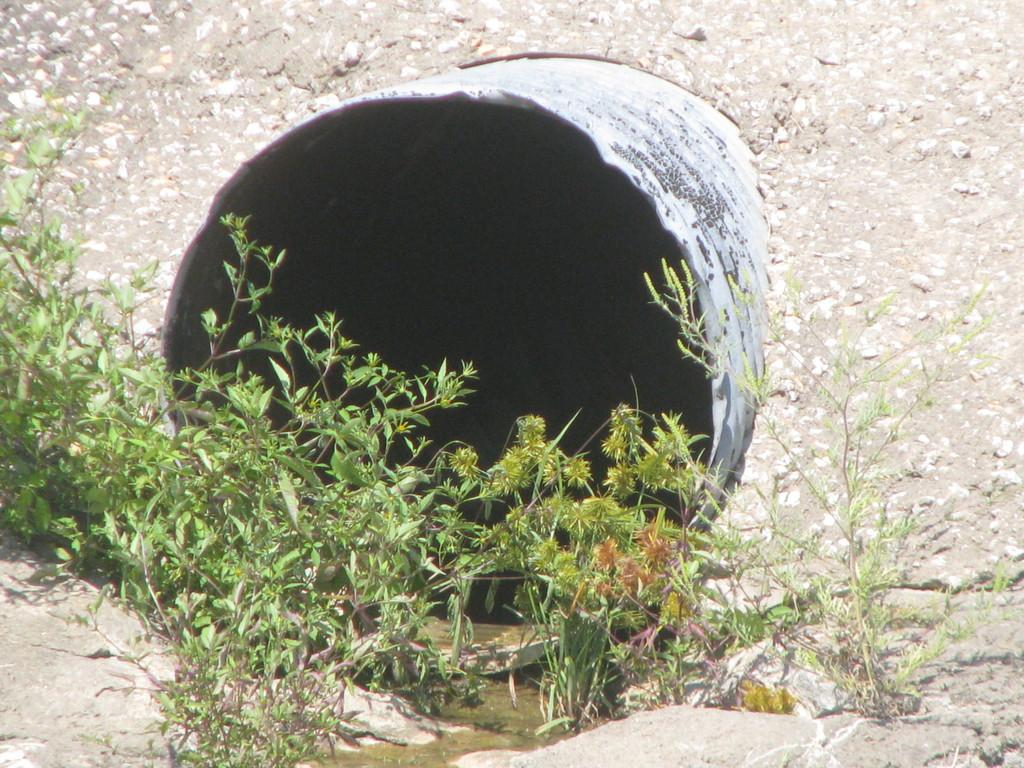What is the main feature in the image? There is a circular shape cement object in the image. What is located in front of the cement object? There are plants in front of the cement object. What can be seen behind the cement object? Land is visible behind the cement object. What type of sleet can be seen falling on the plants in the image? There is no sleet present in the image; it is a clear day with plants in front of the cement object. What answer is being provided by the cement object in the image? The cement object is not providing any answer, as it is an inanimate object. 